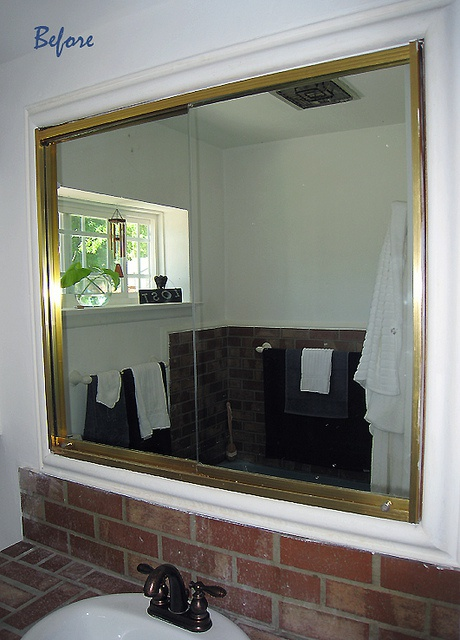Describe the objects in this image and their specific colors. I can see sink in gray, darkgray, and black tones, potted plant in gray, green, darkgray, and ivory tones, and vase in gray, darkgray, ivory, lightgreen, and beige tones in this image. 